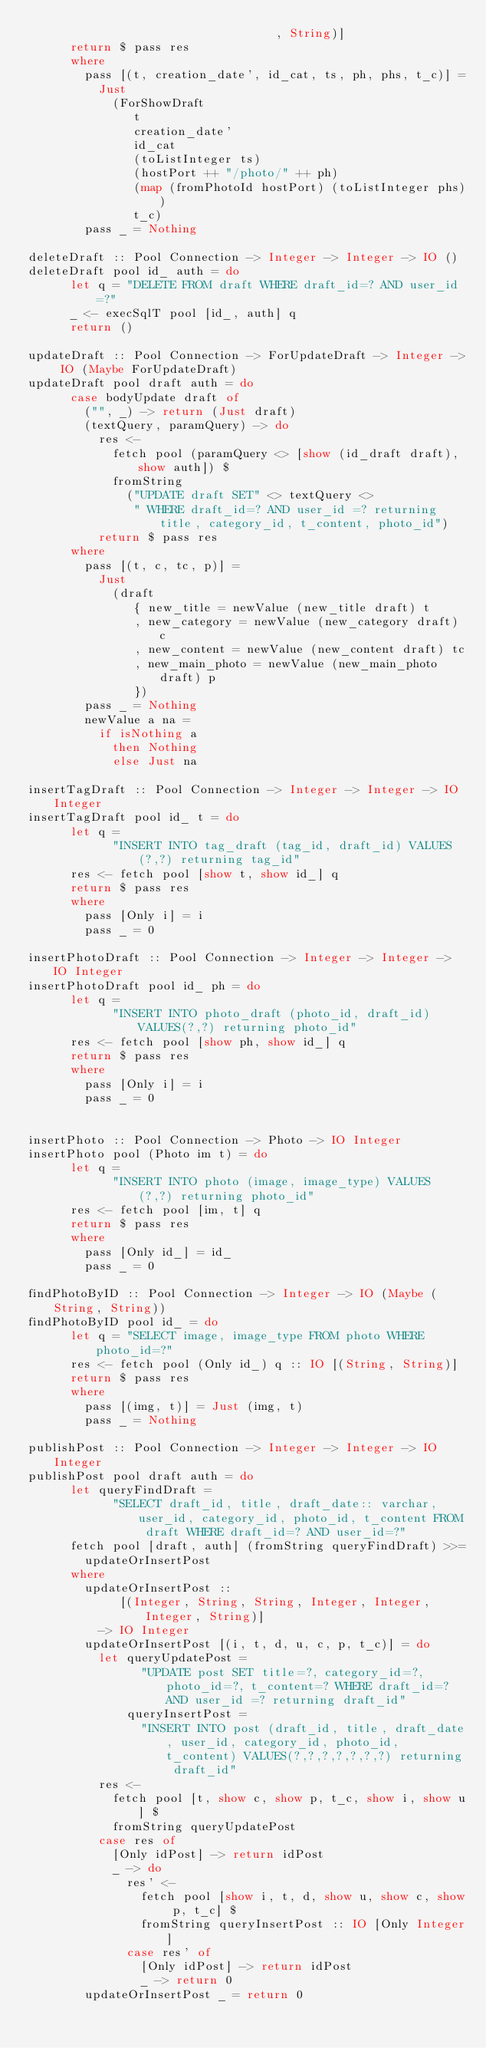<code> <loc_0><loc_0><loc_500><loc_500><_Haskell_>                                   , String)]
      return $ pass res
      where
        pass [(t, creation_date', id_cat, ts, ph, phs, t_c)] =
          Just
            (ForShowDraft
               t
               creation_date'
               id_cat
               (toListInteger ts)
               (hostPort ++ "/photo/" ++ ph)
               (map (fromPhotoId hostPort) (toListInteger phs))
               t_c)
        pass _ = Nothing
        
deleteDraft :: Pool Connection -> Integer -> Integer -> IO ()
deleteDraft pool id_ auth = do
      let q = "DELETE FROM draft WHERE draft_id=? AND user_id =?"
      _ <- execSqlT pool [id_, auth] q
      return ()
      
updateDraft :: Pool Connection -> ForUpdateDraft -> Integer -> IO (Maybe ForUpdateDraft)
updateDraft pool draft auth = do
      case bodyUpdate draft of
        ("", _) -> return (Just draft)
        (textQuery, paramQuery) -> do
          res <-
            fetch pool (paramQuery <> [show (id_draft draft), show auth]) $
            fromString
              ("UPDATE draft SET" <> textQuery <>
               " WHERE draft_id=? AND user_id =? returning title, category_id, t_content, photo_id")
          return $ pass res
      where
        pass [(t, c, tc, p)] =
          Just
            (draft
               { new_title = newValue (new_title draft) t
               , new_category = newValue (new_category draft) c
               , new_content = newValue (new_content draft) tc
               , new_main_photo = newValue (new_main_photo draft) p
               })
        pass _ = Nothing
        newValue a na =
          if isNothing a
            then Nothing
            else Just na
            
insertTagDraft :: Pool Connection -> Integer -> Integer -> IO Integer            
insertTagDraft pool id_ t = do
      let q =
            "INSERT INTO tag_draft (tag_id, draft_id) VALUES(?,?) returning tag_id"
      res <- fetch pool [show t, show id_] q
      return $ pass res
      where
        pass [Only i] = i
        pass _ = 0
        
insertPhotoDraft :: Pool Connection -> Integer -> Integer -> IO Integer       
insertPhotoDraft pool id_ ph = do
      let q =
            "INSERT INTO photo_draft (photo_id, draft_id) VALUES(?,?) returning photo_id"
      res <- fetch pool [show ph, show id_] q
      return $ pass res
      where
        pass [Only i] = i
        pass _ = 0
        

insertPhoto :: Pool Connection -> Photo -> IO Integer
insertPhoto pool (Photo im t) = do
      let q =
            "INSERT INTO photo (image, image_type) VALUES (?,?) returning photo_id"
      res <- fetch pool [im, t] q
      return $ pass res
      where
        pass [Only id_] = id_
        pass _ = 0
        
findPhotoByID :: Pool Connection -> Integer -> IO (Maybe (String, String))        
findPhotoByID pool id_ = do
      let q = "SELECT image, image_type FROM photo WHERE photo_id=?"
      res <- fetch pool (Only id_) q :: IO [(String, String)]
      return $ pass res
      where
        pass [(img, t)] = Just (img, t)
        pass _ = Nothing
        
publishPost :: Pool Connection -> Integer -> Integer -> IO Integer
publishPost pool draft auth = do
      let queryFindDraft =
            "SELECT draft_id, title, draft_date:: varchar, user_id, category_id, photo_id, t_content FROM draft WHERE draft_id=? AND user_id=?"
      fetch pool [draft, auth] (fromString queryFindDraft) >>=
        updateOrInsertPost
      where
        updateOrInsertPost ::
             [(Integer, String, String, Integer, Integer, Integer, String)]
          -> IO Integer
        updateOrInsertPost [(i, t, d, u, c, p, t_c)] = do
          let queryUpdatePost =
                "UPDATE post SET title=?, category_id=?, photo_id=?, t_content=? WHERE draft_id=? AND user_id =? returning draft_id"
              queryInsertPost =
                "INSERT INTO post (draft_id, title, draft_date, user_id, category_id, photo_id, t_content) VALUES(?,?,?,?,?,?,?) returning draft_id"
          res <-
            fetch pool [t, show c, show p, t_c, show i, show u] $
            fromString queryUpdatePost
          case res of
            [Only idPost] -> return idPost
            _ -> do
              res' <-
                fetch pool [show i, t, d, show u, show c, show p, t_c] $
                fromString queryInsertPost :: IO [Only Integer]
              case res' of
                [Only idPost] -> return idPost
                _ -> return 0
        updateOrInsertPost _ = return 0
</code> 